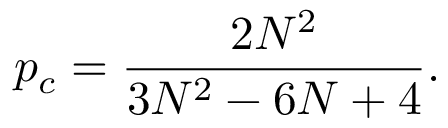<formula> <loc_0><loc_0><loc_500><loc_500>p _ { c } = \frac { 2 N ^ { 2 } } { 3 N ^ { 2 } - 6 N + 4 } .</formula> 